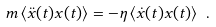<formula> <loc_0><loc_0><loc_500><loc_500>m \, \langle \ddot { x } ( t ) x ( t ) \rangle = - \eta \, \langle \dot { x } ( t ) x ( t ) \rangle \ .</formula> 